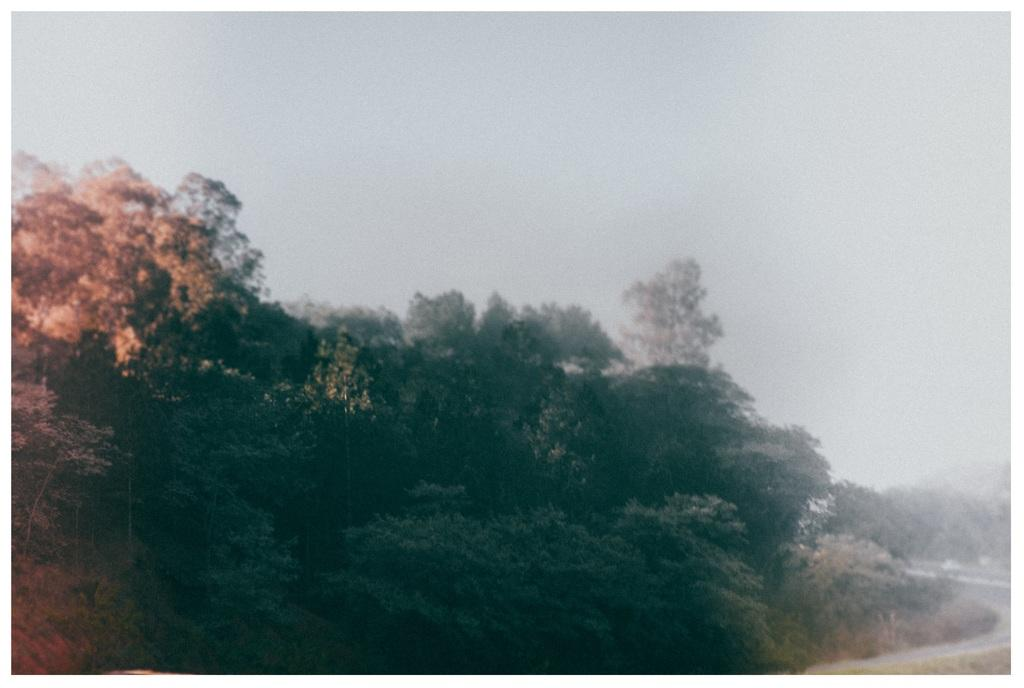What type of vegetation can be seen in the image? There are trees in the image. What is the condition of the sky in the image? The sky is cloudy in the image. What metal object is being turned by the trees in the image? There is no metal object being turned by the trees in the image; the trees are stationary and not interacting with any objects. 